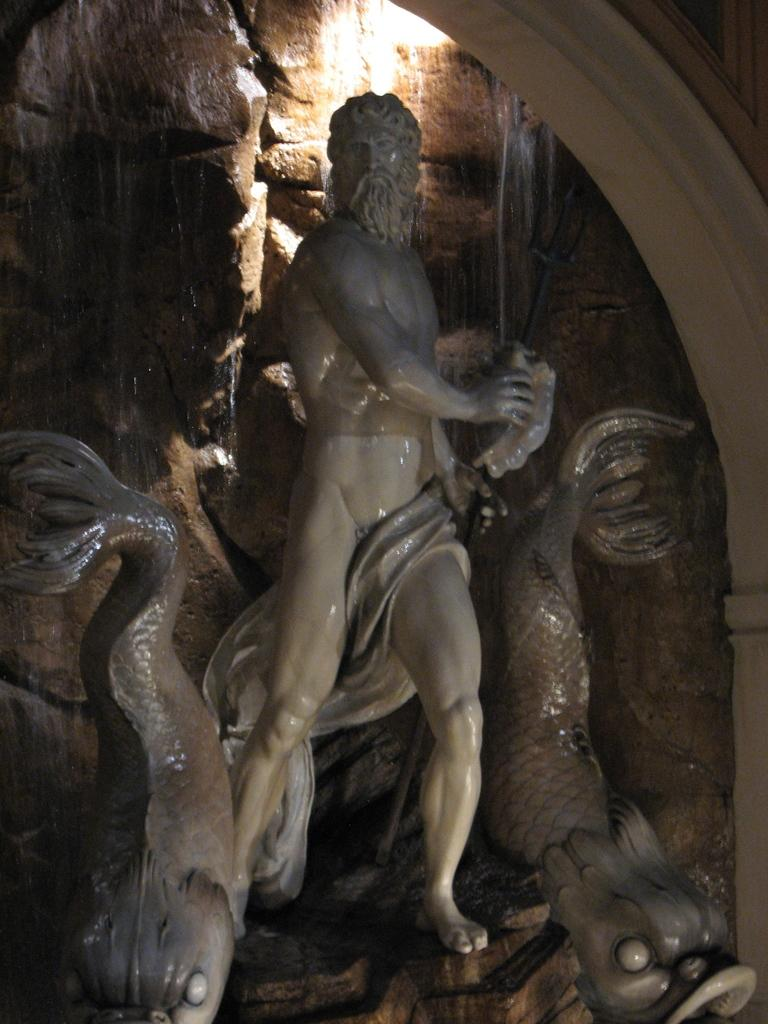What is the main subject of the image? There is a statue of a naked man in the image. Are there any other statues present in the image? Yes, there are fish statues on either side of the naked man statue. What is located behind the statues? There is a stone wall behind the statues. What type of texture can be seen on the potato in the image? There is no potato present in the image; it features statues of a naked man and fish. 